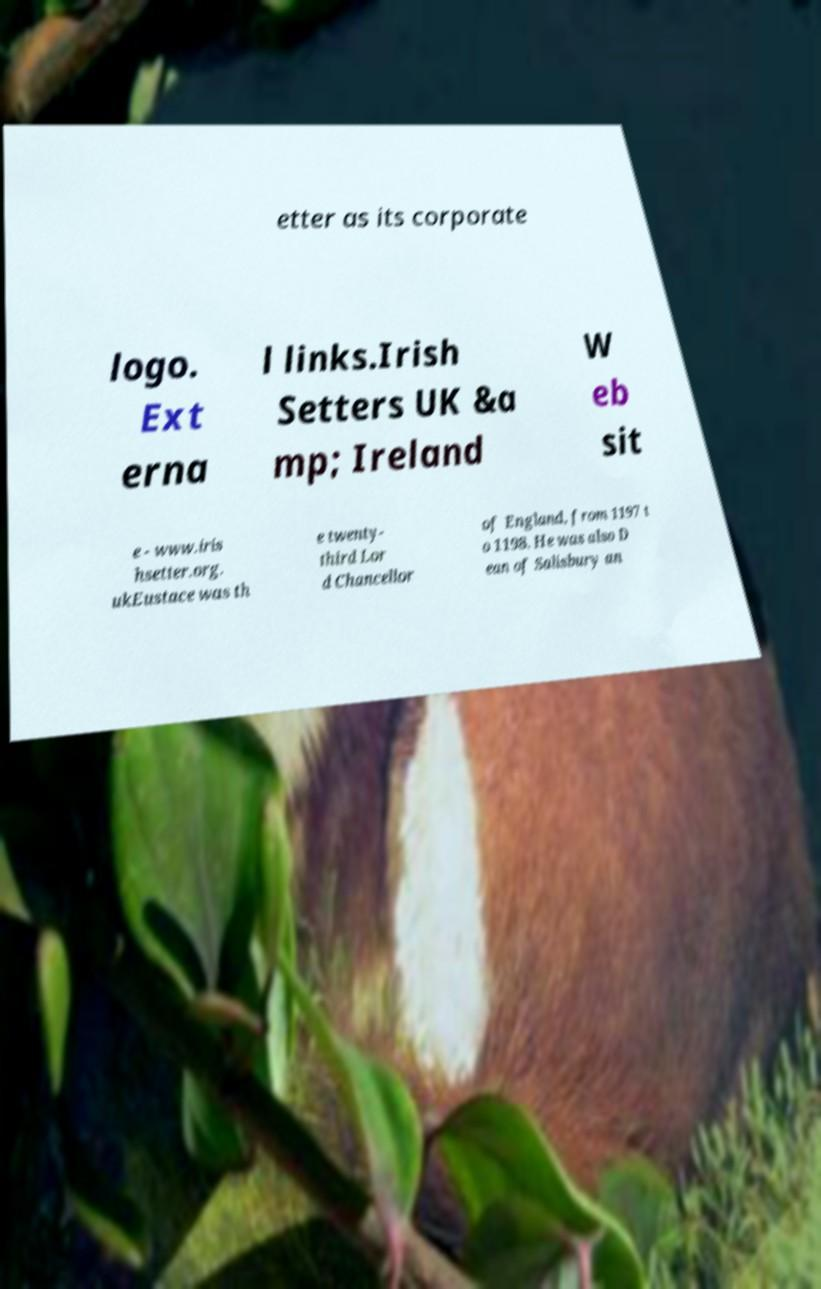Can you read and provide the text displayed in the image?This photo seems to have some interesting text. Can you extract and type it out for me? etter as its corporate logo. Ext erna l links.Irish Setters UK &a mp; Ireland W eb sit e - www.iris hsetter.org. ukEustace was th e twenty- third Lor d Chancellor of England, from 1197 t o 1198. He was also D ean of Salisbury an 